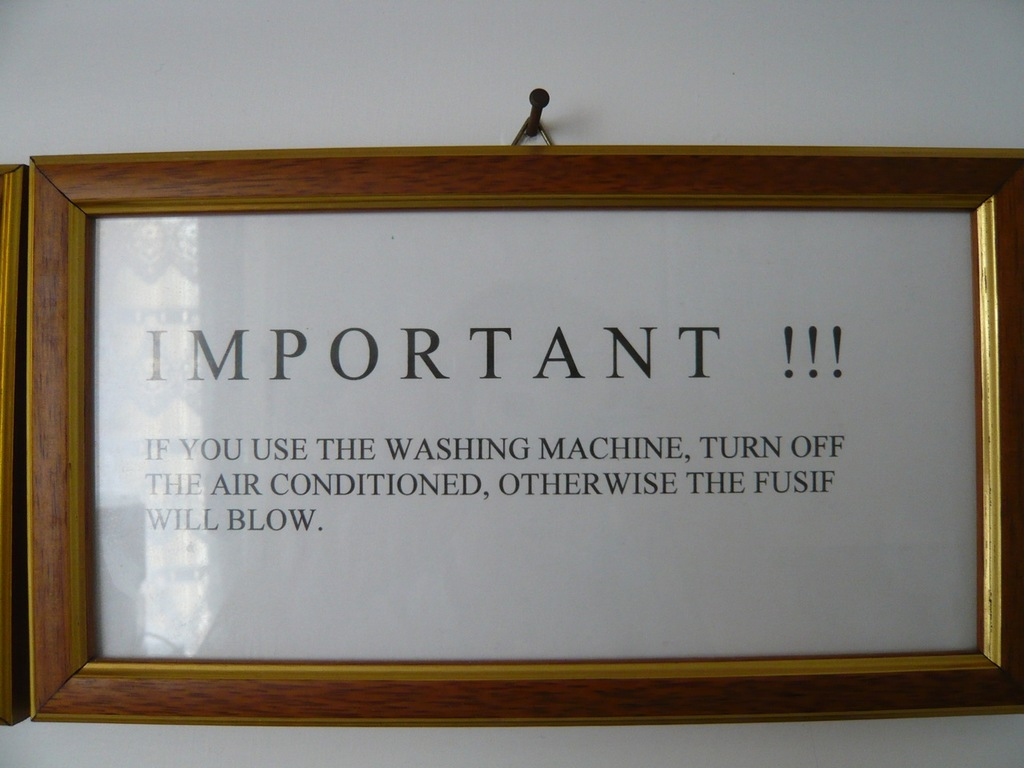What do you see happening in this image? The image shows a notice framed on a white wall. The message is a warning in bold capital letters stating, 'IMPORTANT!!! IF YOU USE THE WASHING MACHINE, TURN OFF THE AIR CONDITIONED, OTHERWISE THE FUSIF WILL BLOW.' This suggests a specific electrical limitation where using both appliances simultaneously might cause a fuse to blow, potentially leading to safety hazards or damage. Such warnings are crucial in places where electrical systems may not support high concurrent electrical load. 